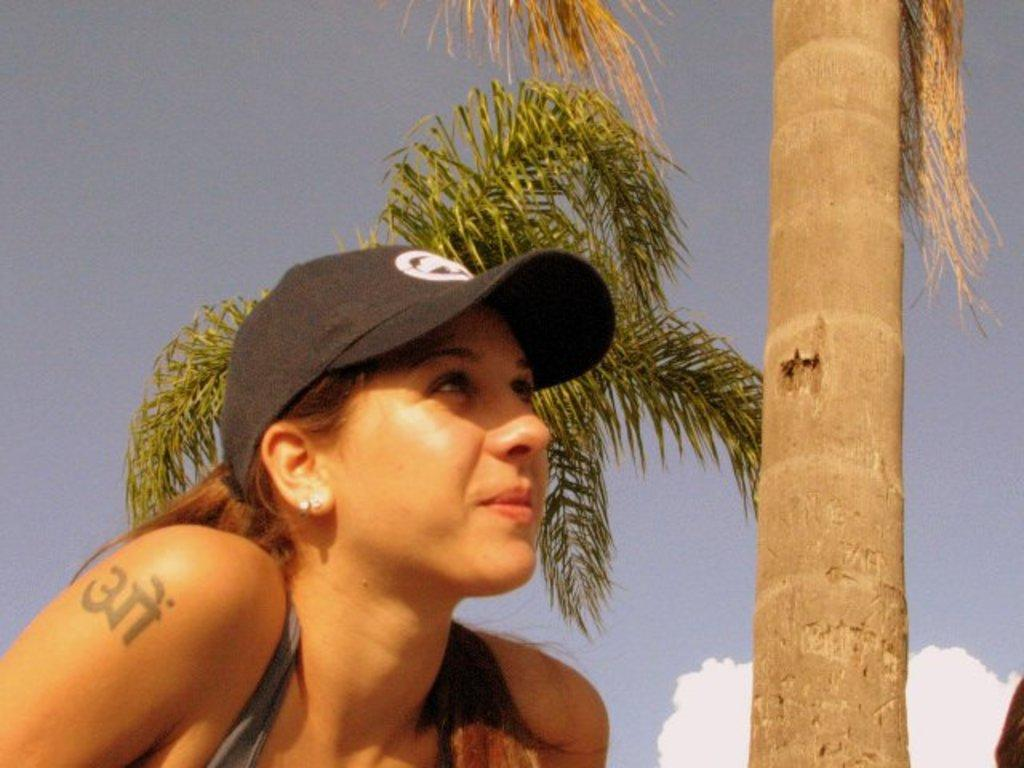Who is the main subject in the image? There is a woman in the image. What is the woman wearing on her head? The woman is wearing a cap. What can be seen in the background of the image? There are trees and the sky visible in the background of the image. What type of mine is visible in the image? There is no mine present in the image; it features a woman wearing a cap with trees and the sky in the background. 